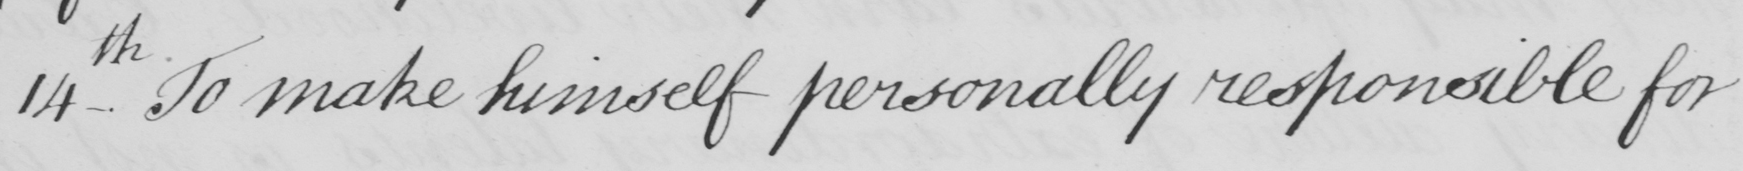Please provide the text content of this handwritten line. 14 _ th To make himself personally responsible for 